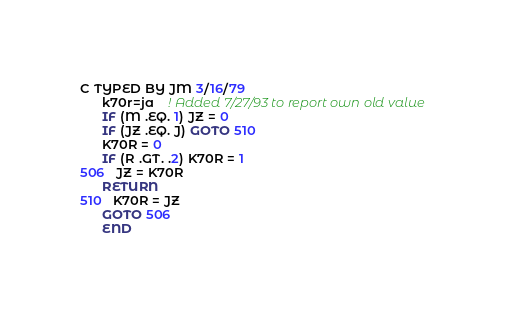Convert code to text. <code><loc_0><loc_0><loc_500><loc_500><_FORTRAN_>C TYPED BY JM 3/16/79
      k70r=ja    ! Added 7/27/93 to report own old value
      IF (M .EQ. 1) JZ = 0
      IF (JZ .EQ. J) GOTO 510
      K70R = 0
      IF (R .GT. .2) K70R = 1
506   JZ = K70R
      RETURN
510   K70R = JZ
      GOTO 506
      END
</code> 